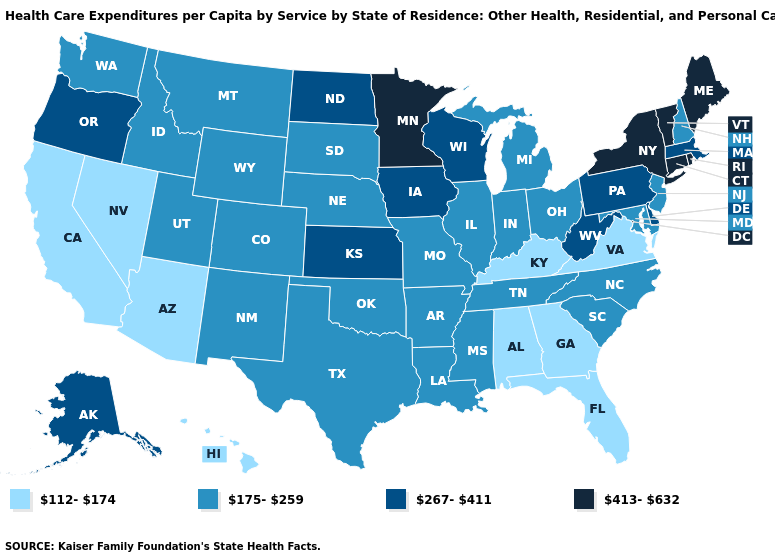What is the value of Connecticut?
Write a very short answer. 413-632. Name the states that have a value in the range 267-411?
Quick response, please. Alaska, Delaware, Iowa, Kansas, Massachusetts, North Dakota, Oregon, Pennsylvania, West Virginia, Wisconsin. Among the states that border Rhode Island , does Massachusetts have the lowest value?
Answer briefly. Yes. What is the value of New Mexico?
Be succinct. 175-259. What is the lowest value in the USA?
Be succinct. 112-174. Name the states that have a value in the range 175-259?
Quick response, please. Arkansas, Colorado, Idaho, Illinois, Indiana, Louisiana, Maryland, Michigan, Mississippi, Missouri, Montana, Nebraska, New Hampshire, New Jersey, New Mexico, North Carolina, Ohio, Oklahoma, South Carolina, South Dakota, Tennessee, Texas, Utah, Washington, Wyoming. Among the states that border Oklahoma , which have the highest value?
Concise answer only. Kansas. What is the highest value in the West ?
Keep it brief. 267-411. Name the states that have a value in the range 413-632?
Quick response, please. Connecticut, Maine, Minnesota, New York, Rhode Island, Vermont. What is the highest value in states that border West Virginia?
Write a very short answer. 267-411. What is the value of Mississippi?
Concise answer only. 175-259. What is the lowest value in states that border Vermont?
Give a very brief answer. 175-259. What is the value of Illinois?
Quick response, please. 175-259. Does Nebraska have a lower value than South Carolina?
Concise answer only. No. What is the value of Ohio?
Be succinct. 175-259. 